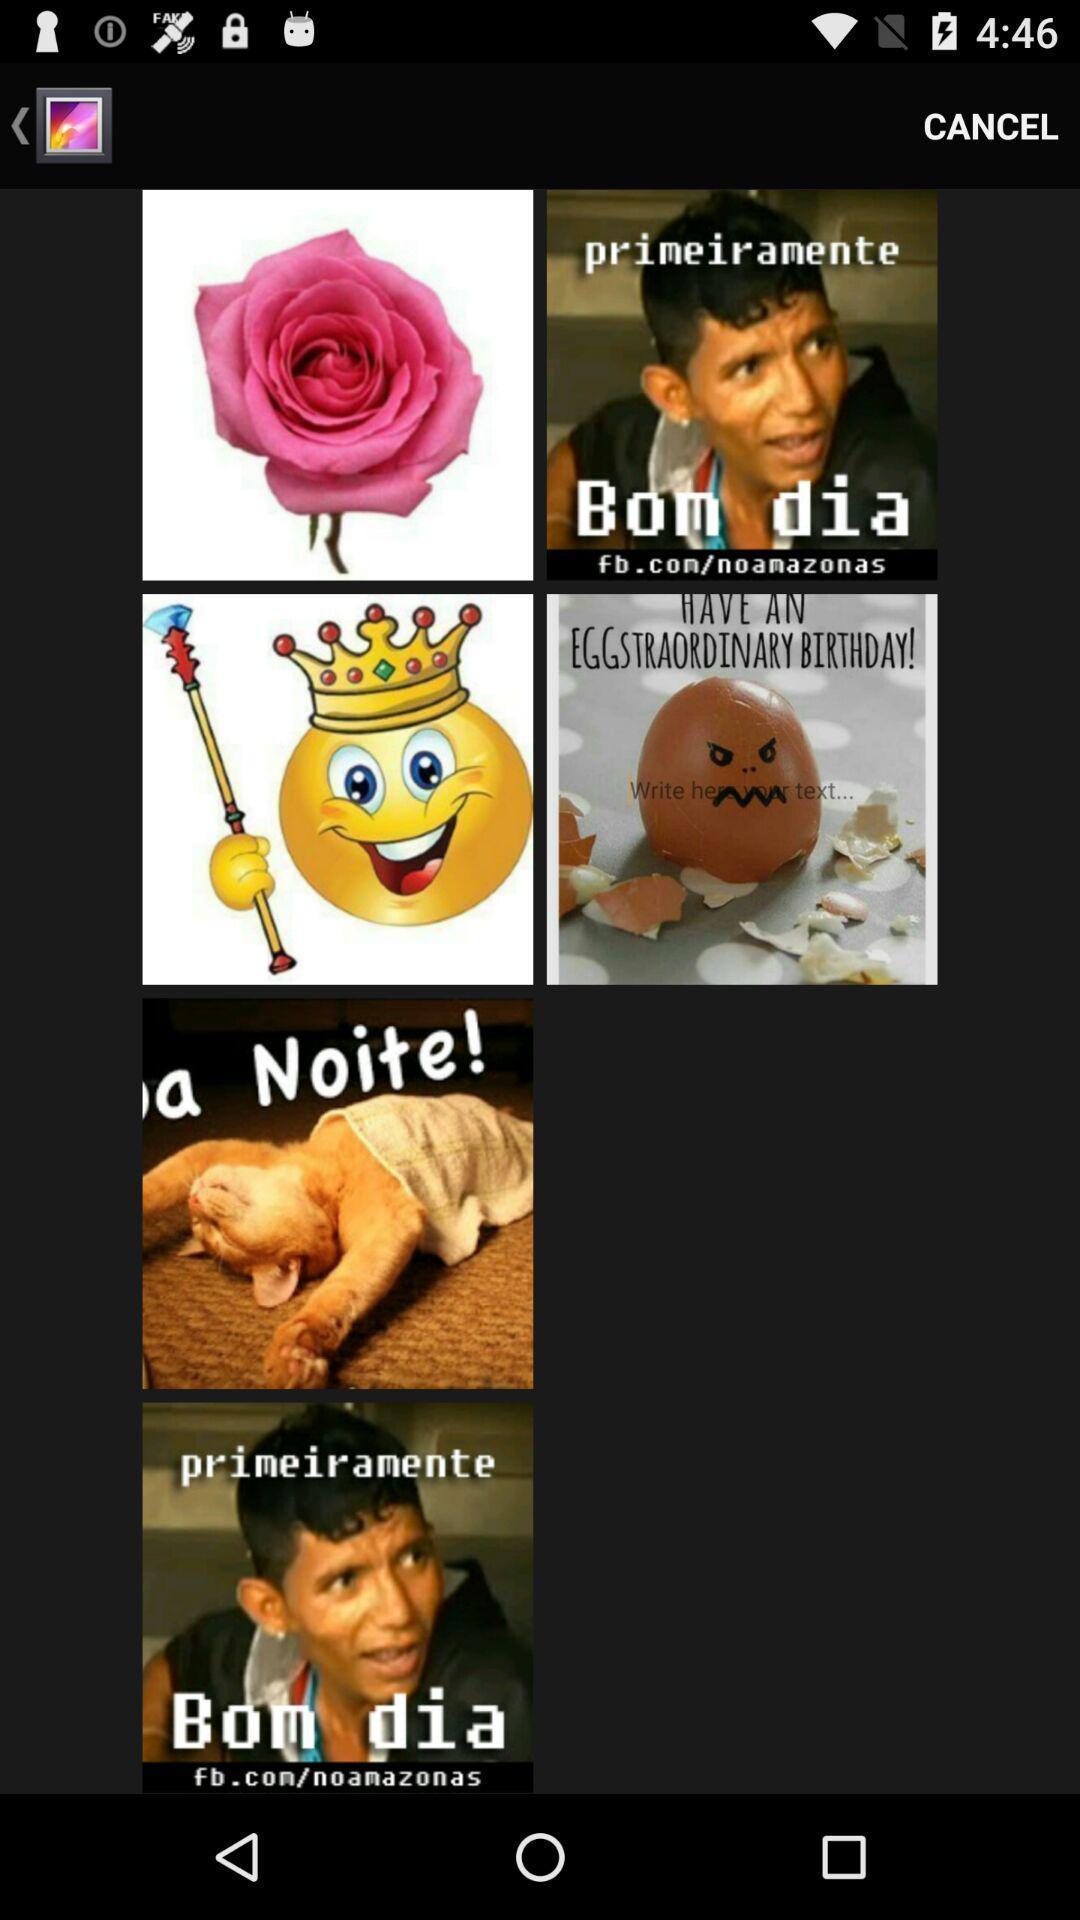Describe the key features of this screenshot. Screen showing pictures in a gallery. 